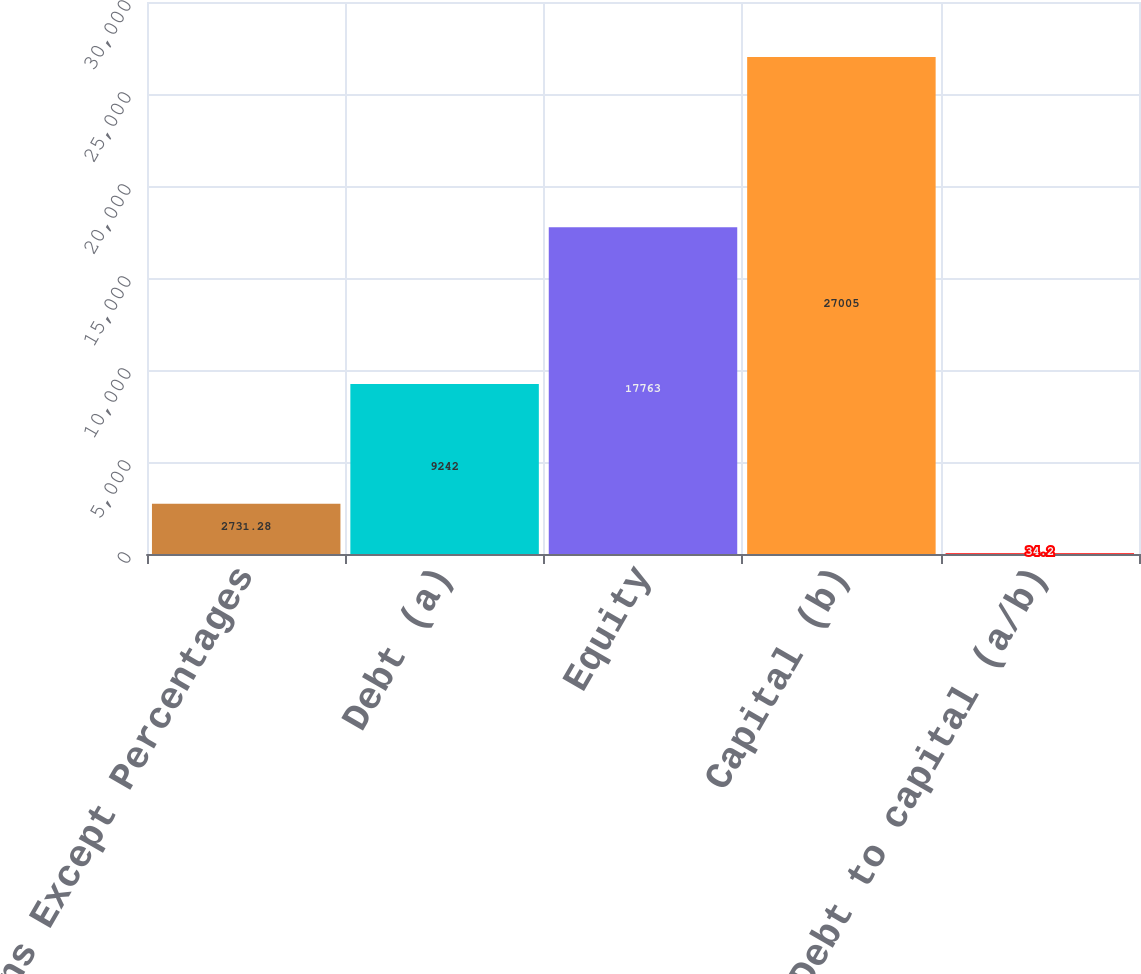<chart> <loc_0><loc_0><loc_500><loc_500><bar_chart><fcel>Millions Except Percentages<fcel>Debt (a)<fcel>Equity<fcel>Capital (b)<fcel>Debt to capital (a/b)<nl><fcel>2731.28<fcel>9242<fcel>17763<fcel>27005<fcel>34.2<nl></chart> 